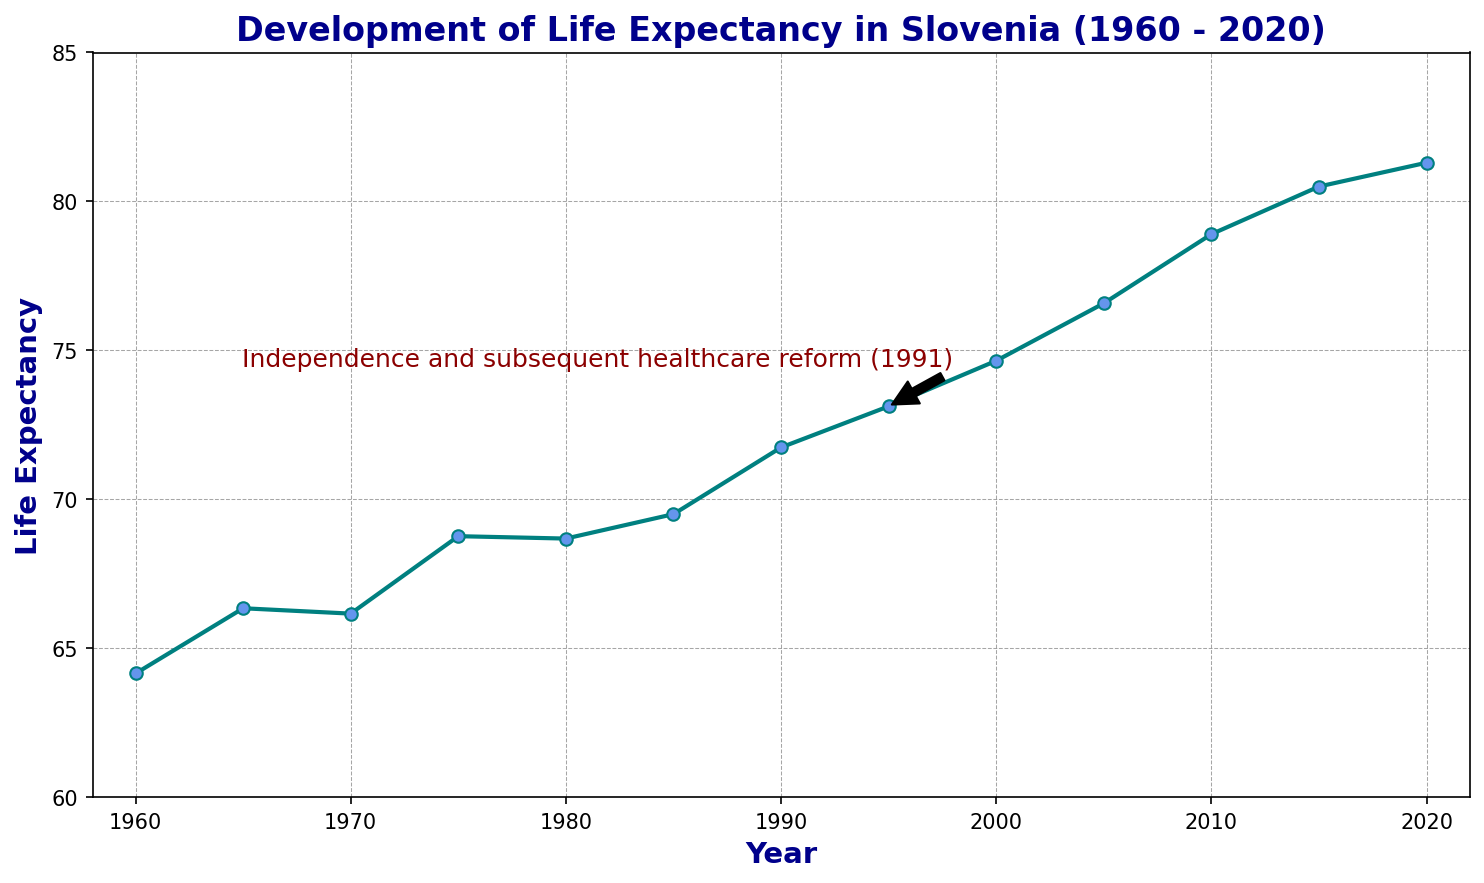What's the overall trend in life expectancy in Slovenia from 1960 to 2020? The graph shows a line moving upward from 1960 to 2020, indicating that life expectancy has generally increased over time.
Answer: Increasing How did life expectancy change between 1980 and 1990? By comparing the values at 1980 (68.68) and 1990 (71.74), we see an increase. The difference can be calculated as 71.74 - 68.68.
Answer: Increased by 3.06 years What significant event is annotated in the chart and what impact did it have on life expectancy? The annotation on the chart mentions "Independence and subsequent healthcare reform (1991)". Observing the life expectancy values before and after 1991, there is a noticeable increase from 1991 (71.74) to 1995 (73.12).
Answer: Healthcare reform and independence Which period shows the most significant increase in life expectancy? Observing the slopes of the line, the steepest increase occurs between 2005 (76.58) and 2010 (78.90). The change can be calculated as 78.90 - 76.58.
Answer: 2005-2010 Did the life expectancy ever decrease within the timeframe shown? Checking the line graph, there is a slight dip between 1970 (66.16) and 1975 (68.76); however, this is a small increase rather than a decrease. The overall trend from 1960 to 2020 does not show any downward movement.
Answer: No What's the average life expectancy from 1960 to 2020? Sum up all the life expectancy values and divide by the number of years: (64.15 + 66.34 + 66.16 + 68.76 + 68.68 + 69.50 + 71.74 + 73.12 + 74.65 + 76.58 + 78.90 + 80.50 + 81.30) / 13.
Answer: 72.95 years What was the life expectancy in Slovenia in 1960 compared to 2020? From the graph, the life expectancy in 1960 is 64.15 and in 2020 is 81.30, indicating an increase. We can calculate the difference as 81.30 - 64.15.
Answer: Increased by 17.15 years Which decade showed the least improvement in life expectancy? By analyzing the changes per decade, we observe the following annual changes:
- 1960-1970: 66.16 - 64.15 = 2.01
- 1970-1980: 68.68 - 66.16 = 2.52
- 1980-1990: 71.74 - 68.68 = 3.06
- 1990-2000: 74.65 - 71.74 = 2.91
- 2000-2010: 78.90 - 74.65 = 4.25
- 2010-2020: 81.30 - 78.90 = 2.40
The decade from 1960 to 1970 shows the least improvement of 2.01.
Answer: 1960-1970 When does the life expectancy exceed 70 years for the first time? Referring to the graph, life expectancy exceeds 70 years in 1990 with a value of 71.74.
Answer: 1990 Which year marked the highest life expectancy in the data provided and what was the value? Inspecting the endpoints of the graph, the highest value is at the year 2020 with a life expectancy of 81.30.
Answer: 2020, 81.30 